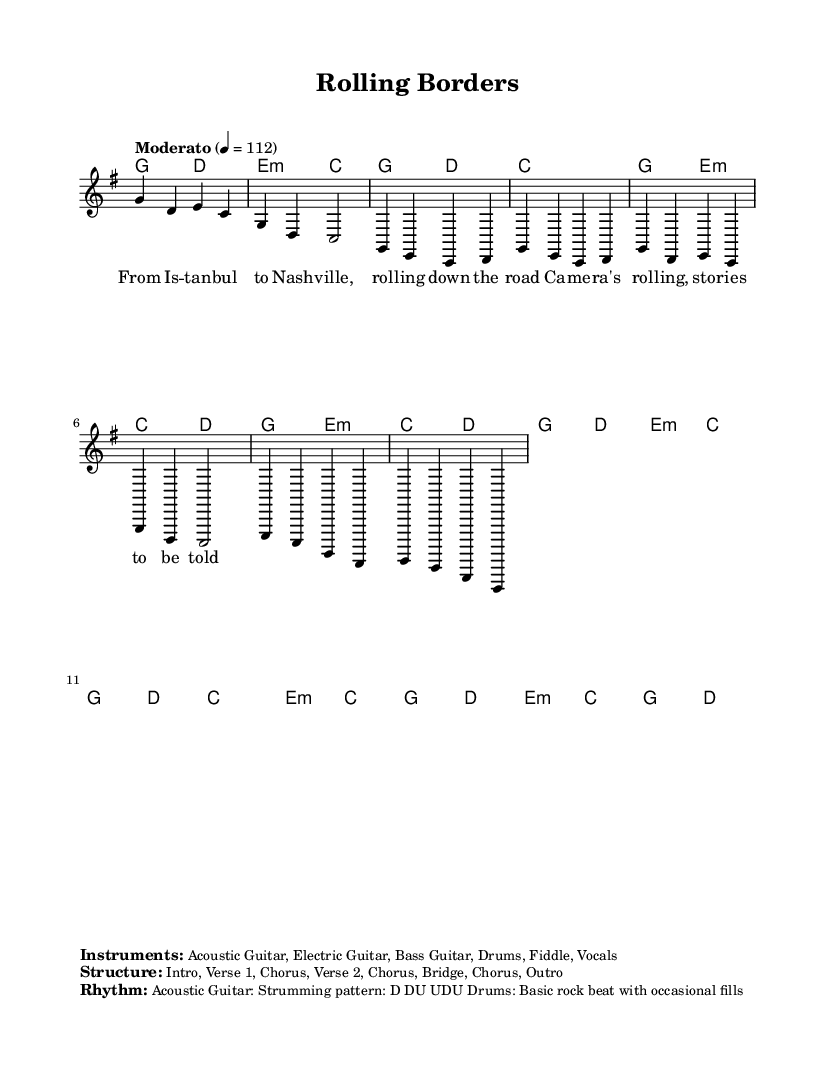What is the key signature of this music? The key signature indicated is G major, which has one sharp (F#).
Answer: G major What is the time signature of this music? The time signature shown is 4/4, meaning there are four beats in each measure.
Answer: 4/4 What is the tempo marking for this piece? The tempo marking provided is "Moderato," with a metronome marking of 112 beats per minute.
Answer: Moderato, 112 How many sections are included in the structure of this piece? The structure is composed of eight sections: Intro, Verse 1, Chorus, Verse 2, Chorus, Bridge, Chorus, Outro. Counting these sections gives the total.
Answer: Eight sections What is the strumming pattern for the acoustic guitar? The strumming pattern indicated for the acoustic guitar is D DU UDU, which consists of down and up strokes.
Answer: D DU UDU What instruments are featured in this piece? The text specifies the instruments as Acoustic Guitar, Electric Guitar, Bass Guitar, Drums, Fiddle, and Vocals, indicating a typical country rock ensemble.
Answer: Acoustic Guitar, Electric Guitar, Bass Guitar, Drums, Fiddle, Vocals What type of beat do the drums follow in this music? The drums are indicated to play a basic rock beat with occasional fills, reflecting the country rock style commonly characterized by a strong backbeat.
Answer: Basic rock beat 